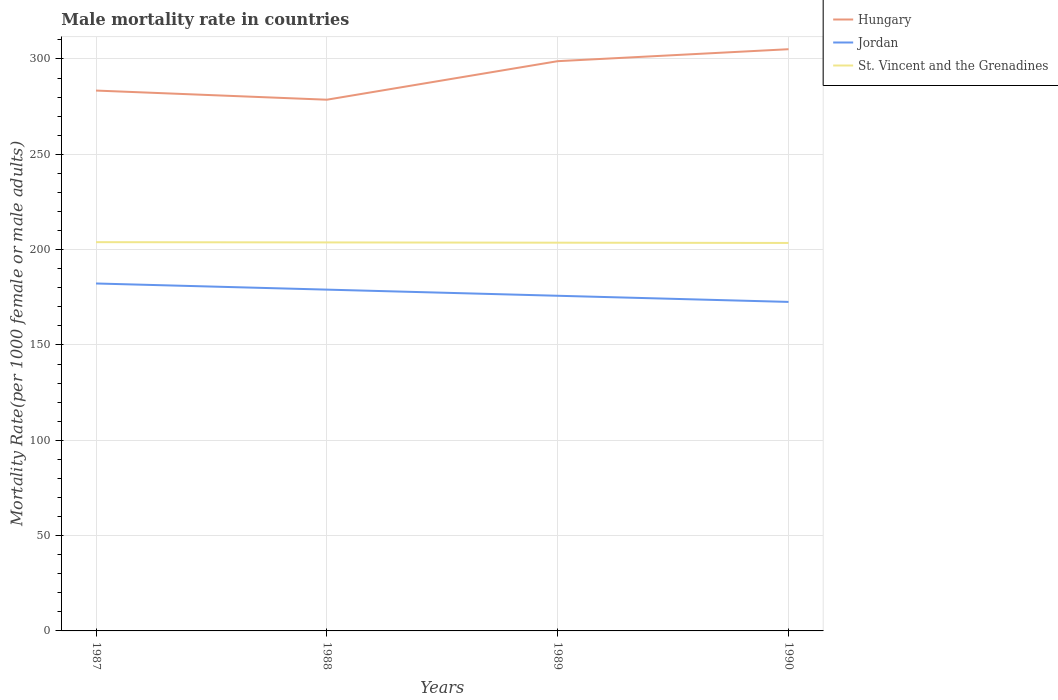How many different coloured lines are there?
Offer a terse response. 3. Does the line corresponding to St. Vincent and the Grenadines intersect with the line corresponding to Hungary?
Give a very brief answer. No. Across all years, what is the maximum male mortality rate in St. Vincent and the Grenadines?
Provide a succinct answer. 203.49. In which year was the male mortality rate in St. Vincent and the Grenadines maximum?
Offer a very short reply. 1990. What is the total male mortality rate in Hungary in the graph?
Provide a succinct answer. -21.69. What is the difference between the highest and the second highest male mortality rate in Jordan?
Offer a terse response. 9.67. Is the male mortality rate in St. Vincent and the Grenadines strictly greater than the male mortality rate in Jordan over the years?
Keep it short and to the point. No. How many lines are there?
Provide a short and direct response. 3. How many years are there in the graph?
Provide a succinct answer. 4. What is the difference between two consecutive major ticks on the Y-axis?
Your response must be concise. 50. Are the values on the major ticks of Y-axis written in scientific E-notation?
Make the answer very short. No. How many legend labels are there?
Offer a terse response. 3. How are the legend labels stacked?
Your response must be concise. Vertical. What is the title of the graph?
Offer a very short reply. Male mortality rate in countries. What is the label or title of the Y-axis?
Keep it short and to the point. Mortality Rate(per 1000 female or male adults). What is the Mortality Rate(per 1000 female or male adults) of Hungary in 1987?
Provide a short and direct response. 283.43. What is the Mortality Rate(per 1000 female or male adults) in Jordan in 1987?
Your answer should be very brief. 182.24. What is the Mortality Rate(per 1000 female or male adults) in St. Vincent and the Grenadines in 1987?
Keep it short and to the point. 203.91. What is the Mortality Rate(per 1000 female or male adults) of Hungary in 1988?
Make the answer very short. 278.63. What is the Mortality Rate(per 1000 female or male adults) of Jordan in 1988?
Your answer should be very brief. 179.02. What is the Mortality Rate(per 1000 female or male adults) of St. Vincent and the Grenadines in 1988?
Give a very brief answer. 203.77. What is the Mortality Rate(per 1000 female or male adults) in Hungary in 1989?
Keep it short and to the point. 298.84. What is the Mortality Rate(per 1000 female or male adults) in Jordan in 1989?
Your answer should be very brief. 175.79. What is the Mortality Rate(per 1000 female or male adults) of St. Vincent and the Grenadines in 1989?
Offer a terse response. 203.63. What is the Mortality Rate(per 1000 female or male adults) of Hungary in 1990?
Offer a terse response. 305.11. What is the Mortality Rate(per 1000 female or male adults) of Jordan in 1990?
Your answer should be very brief. 172.57. What is the Mortality Rate(per 1000 female or male adults) in St. Vincent and the Grenadines in 1990?
Provide a succinct answer. 203.49. Across all years, what is the maximum Mortality Rate(per 1000 female or male adults) of Hungary?
Provide a succinct answer. 305.11. Across all years, what is the maximum Mortality Rate(per 1000 female or male adults) in Jordan?
Keep it short and to the point. 182.24. Across all years, what is the maximum Mortality Rate(per 1000 female or male adults) of St. Vincent and the Grenadines?
Provide a short and direct response. 203.91. Across all years, what is the minimum Mortality Rate(per 1000 female or male adults) in Hungary?
Offer a terse response. 278.63. Across all years, what is the minimum Mortality Rate(per 1000 female or male adults) in Jordan?
Provide a succinct answer. 172.57. Across all years, what is the minimum Mortality Rate(per 1000 female or male adults) of St. Vincent and the Grenadines?
Your answer should be compact. 203.49. What is the total Mortality Rate(per 1000 female or male adults) in Hungary in the graph?
Give a very brief answer. 1166.01. What is the total Mortality Rate(per 1000 female or male adults) in Jordan in the graph?
Your response must be concise. 709.62. What is the total Mortality Rate(per 1000 female or male adults) of St. Vincent and the Grenadines in the graph?
Provide a short and direct response. 814.81. What is the difference between the Mortality Rate(per 1000 female or male adults) in Hungary in 1987 and that in 1988?
Ensure brevity in your answer.  4.79. What is the difference between the Mortality Rate(per 1000 female or male adults) of Jordan in 1987 and that in 1988?
Give a very brief answer. 3.22. What is the difference between the Mortality Rate(per 1000 female or male adults) of St. Vincent and the Grenadines in 1987 and that in 1988?
Your answer should be compact. 0.14. What is the difference between the Mortality Rate(per 1000 female or male adults) in Hungary in 1987 and that in 1989?
Your answer should be very brief. -15.41. What is the difference between the Mortality Rate(per 1000 female or male adults) of Jordan in 1987 and that in 1989?
Your answer should be very brief. 6.44. What is the difference between the Mortality Rate(per 1000 female or male adults) of St. Vincent and the Grenadines in 1987 and that in 1989?
Keep it short and to the point. 0.28. What is the difference between the Mortality Rate(per 1000 female or male adults) in Hungary in 1987 and that in 1990?
Your answer should be compact. -21.69. What is the difference between the Mortality Rate(per 1000 female or male adults) in Jordan in 1987 and that in 1990?
Your answer should be very brief. 9.67. What is the difference between the Mortality Rate(per 1000 female or male adults) in St. Vincent and the Grenadines in 1987 and that in 1990?
Offer a terse response. 0.41. What is the difference between the Mortality Rate(per 1000 female or male adults) in Hungary in 1988 and that in 1989?
Make the answer very short. -20.21. What is the difference between the Mortality Rate(per 1000 female or male adults) of Jordan in 1988 and that in 1989?
Ensure brevity in your answer.  3.22. What is the difference between the Mortality Rate(per 1000 female or male adults) of St. Vincent and the Grenadines in 1988 and that in 1989?
Make the answer very short. 0.14. What is the difference between the Mortality Rate(per 1000 female or male adults) in Hungary in 1988 and that in 1990?
Ensure brevity in your answer.  -26.48. What is the difference between the Mortality Rate(per 1000 female or male adults) in Jordan in 1988 and that in 1990?
Your response must be concise. 6.44. What is the difference between the Mortality Rate(per 1000 female or male adults) of St. Vincent and the Grenadines in 1988 and that in 1990?
Make the answer very short. 0.28. What is the difference between the Mortality Rate(per 1000 female or male adults) in Hungary in 1989 and that in 1990?
Provide a succinct answer. -6.28. What is the difference between the Mortality Rate(per 1000 female or male adults) in Jordan in 1989 and that in 1990?
Give a very brief answer. 3.22. What is the difference between the Mortality Rate(per 1000 female or male adults) of St. Vincent and the Grenadines in 1989 and that in 1990?
Your answer should be very brief. 0.14. What is the difference between the Mortality Rate(per 1000 female or male adults) of Hungary in 1987 and the Mortality Rate(per 1000 female or male adults) of Jordan in 1988?
Provide a short and direct response. 104.41. What is the difference between the Mortality Rate(per 1000 female or male adults) in Hungary in 1987 and the Mortality Rate(per 1000 female or male adults) in St. Vincent and the Grenadines in 1988?
Your answer should be compact. 79.65. What is the difference between the Mortality Rate(per 1000 female or male adults) of Jordan in 1987 and the Mortality Rate(per 1000 female or male adults) of St. Vincent and the Grenadines in 1988?
Provide a succinct answer. -21.53. What is the difference between the Mortality Rate(per 1000 female or male adults) of Hungary in 1987 and the Mortality Rate(per 1000 female or male adults) of Jordan in 1989?
Provide a succinct answer. 107.63. What is the difference between the Mortality Rate(per 1000 female or male adults) in Hungary in 1987 and the Mortality Rate(per 1000 female or male adults) in St. Vincent and the Grenadines in 1989?
Give a very brief answer. 79.79. What is the difference between the Mortality Rate(per 1000 female or male adults) in Jordan in 1987 and the Mortality Rate(per 1000 female or male adults) in St. Vincent and the Grenadines in 1989?
Make the answer very short. -21.39. What is the difference between the Mortality Rate(per 1000 female or male adults) of Hungary in 1987 and the Mortality Rate(per 1000 female or male adults) of Jordan in 1990?
Your answer should be compact. 110.85. What is the difference between the Mortality Rate(per 1000 female or male adults) in Hungary in 1987 and the Mortality Rate(per 1000 female or male adults) in St. Vincent and the Grenadines in 1990?
Give a very brief answer. 79.93. What is the difference between the Mortality Rate(per 1000 female or male adults) of Jordan in 1987 and the Mortality Rate(per 1000 female or male adults) of St. Vincent and the Grenadines in 1990?
Provide a succinct answer. -21.26. What is the difference between the Mortality Rate(per 1000 female or male adults) of Hungary in 1988 and the Mortality Rate(per 1000 female or male adults) of Jordan in 1989?
Offer a terse response. 102.84. What is the difference between the Mortality Rate(per 1000 female or male adults) of Hungary in 1988 and the Mortality Rate(per 1000 female or male adults) of St. Vincent and the Grenadines in 1989?
Offer a terse response. 75. What is the difference between the Mortality Rate(per 1000 female or male adults) in Jordan in 1988 and the Mortality Rate(per 1000 female or male adults) in St. Vincent and the Grenadines in 1989?
Keep it short and to the point. -24.62. What is the difference between the Mortality Rate(per 1000 female or male adults) in Hungary in 1988 and the Mortality Rate(per 1000 female or male adults) in Jordan in 1990?
Make the answer very short. 106.06. What is the difference between the Mortality Rate(per 1000 female or male adults) of Hungary in 1988 and the Mortality Rate(per 1000 female or male adults) of St. Vincent and the Grenadines in 1990?
Provide a succinct answer. 75.14. What is the difference between the Mortality Rate(per 1000 female or male adults) in Jordan in 1988 and the Mortality Rate(per 1000 female or male adults) in St. Vincent and the Grenadines in 1990?
Give a very brief answer. -24.48. What is the difference between the Mortality Rate(per 1000 female or male adults) in Hungary in 1989 and the Mortality Rate(per 1000 female or male adults) in Jordan in 1990?
Offer a very short reply. 126.27. What is the difference between the Mortality Rate(per 1000 female or male adults) in Hungary in 1989 and the Mortality Rate(per 1000 female or male adults) in St. Vincent and the Grenadines in 1990?
Ensure brevity in your answer.  95.34. What is the difference between the Mortality Rate(per 1000 female or male adults) of Jordan in 1989 and the Mortality Rate(per 1000 female or male adults) of St. Vincent and the Grenadines in 1990?
Provide a short and direct response. -27.7. What is the average Mortality Rate(per 1000 female or male adults) in Hungary per year?
Your answer should be very brief. 291.5. What is the average Mortality Rate(per 1000 female or male adults) of Jordan per year?
Give a very brief answer. 177.4. What is the average Mortality Rate(per 1000 female or male adults) of St. Vincent and the Grenadines per year?
Your response must be concise. 203.7. In the year 1987, what is the difference between the Mortality Rate(per 1000 female or male adults) in Hungary and Mortality Rate(per 1000 female or male adults) in Jordan?
Provide a short and direct response. 101.19. In the year 1987, what is the difference between the Mortality Rate(per 1000 female or male adults) in Hungary and Mortality Rate(per 1000 female or male adults) in St. Vincent and the Grenadines?
Provide a short and direct response. 79.52. In the year 1987, what is the difference between the Mortality Rate(per 1000 female or male adults) in Jordan and Mortality Rate(per 1000 female or male adults) in St. Vincent and the Grenadines?
Provide a short and direct response. -21.67. In the year 1988, what is the difference between the Mortality Rate(per 1000 female or male adults) of Hungary and Mortality Rate(per 1000 female or male adults) of Jordan?
Your response must be concise. 99.62. In the year 1988, what is the difference between the Mortality Rate(per 1000 female or male adults) of Hungary and Mortality Rate(per 1000 female or male adults) of St. Vincent and the Grenadines?
Provide a short and direct response. 74.86. In the year 1988, what is the difference between the Mortality Rate(per 1000 female or male adults) in Jordan and Mortality Rate(per 1000 female or male adults) in St. Vincent and the Grenadines?
Keep it short and to the point. -24.76. In the year 1989, what is the difference between the Mortality Rate(per 1000 female or male adults) of Hungary and Mortality Rate(per 1000 female or male adults) of Jordan?
Offer a very short reply. 123.05. In the year 1989, what is the difference between the Mortality Rate(per 1000 female or male adults) in Hungary and Mortality Rate(per 1000 female or male adults) in St. Vincent and the Grenadines?
Offer a very short reply. 95.21. In the year 1989, what is the difference between the Mortality Rate(per 1000 female or male adults) in Jordan and Mortality Rate(per 1000 female or male adults) in St. Vincent and the Grenadines?
Ensure brevity in your answer.  -27.84. In the year 1990, what is the difference between the Mortality Rate(per 1000 female or male adults) of Hungary and Mortality Rate(per 1000 female or male adults) of Jordan?
Offer a very short reply. 132.54. In the year 1990, what is the difference between the Mortality Rate(per 1000 female or male adults) in Hungary and Mortality Rate(per 1000 female or male adults) in St. Vincent and the Grenadines?
Your response must be concise. 101.62. In the year 1990, what is the difference between the Mortality Rate(per 1000 female or male adults) of Jordan and Mortality Rate(per 1000 female or male adults) of St. Vincent and the Grenadines?
Provide a succinct answer. -30.92. What is the ratio of the Mortality Rate(per 1000 female or male adults) of Hungary in 1987 to that in 1988?
Provide a short and direct response. 1.02. What is the ratio of the Mortality Rate(per 1000 female or male adults) of Jordan in 1987 to that in 1988?
Your response must be concise. 1.02. What is the ratio of the Mortality Rate(per 1000 female or male adults) of Hungary in 1987 to that in 1989?
Your response must be concise. 0.95. What is the ratio of the Mortality Rate(per 1000 female or male adults) of Jordan in 1987 to that in 1989?
Provide a short and direct response. 1.04. What is the ratio of the Mortality Rate(per 1000 female or male adults) of St. Vincent and the Grenadines in 1987 to that in 1989?
Make the answer very short. 1. What is the ratio of the Mortality Rate(per 1000 female or male adults) in Hungary in 1987 to that in 1990?
Provide a succinct answer. 0.93. What is the ratio of the Mortality Rate(per 1000 female or male adults) in Jordan in 1987 to that in 1990?
Give a very brief answer. 1.06. What is the ratio of the Mortality Rate(per 1000 female or male adults) in St. Vincent and the Grenadines in 1987 to that in 1990?
Your answer should be very brief. 1. What is the ratio of the Mortality Rate(per 1000 female or male adults) of Hungary in 1988 to that in 1989?
Your answer should be very brief. 0.93. What is the ratio of the Mortality Rate(per 1000 female or male adults) of Jordan in 1988 to that in 1989?
Your answer should be very brief. 1.02. What is the ratio of the Mortality Rate(per 1000 female or male adults) in Hungary in 1988 to that in 1990?
Provide a succinct answer. 0.91. What is the ratio of the Mortality Rate(per 1000 female or male adults) of Jordan in 1988 to that in 1990?
Your response must be concise. 1.04. What is the ratio of the Mortality Rate(per 1000 female or male adults) of Hungary in 1989 to that in 1990?
Provide a succinct answer. 0.98. What is the ratio of the Mortality Rate(per 1000 female or male adults) in Jordan in 1989 to that in 1990?
Offer a terse response. 1.02. What is the ratio of the Mortality Rate(per 1000 female or male adults) of St. Vincent and the Grenadines in 1989 to that in 1990?
Offer a terse response. 1. What is the difference between the highest and the second highest Mortality Rate(per 1000 female or male adults) of Hungary?
Ensure brevity in your answer.  6.28. What is the difference between the highest and the second highest Mortality Rate(per 1000 female or male adults) in Jordan?
Offer a terse response. 3.22. What is the difference between the highest and the second highest Mortality Rate(per 1000 female or male adults) in St. Vincent and the Grenadines?
Make the answer very short. 0.14. What is the difference between the highest and the lowest Mortality Rate(per 1000 female or male adults) of Hungary?
Give a very brief answer. 26.48. What is the difference between the highest and the lowest Mortality Rate(per 1000 female or male adults) in Jordan?
Give a very brief answer. 9.67. What is the difference between the highest and the lowest Mortality Rate(per 1000 female or male adults) in St. Vincent and the Grenadines?
Your answer should be very brief. 0.41. 